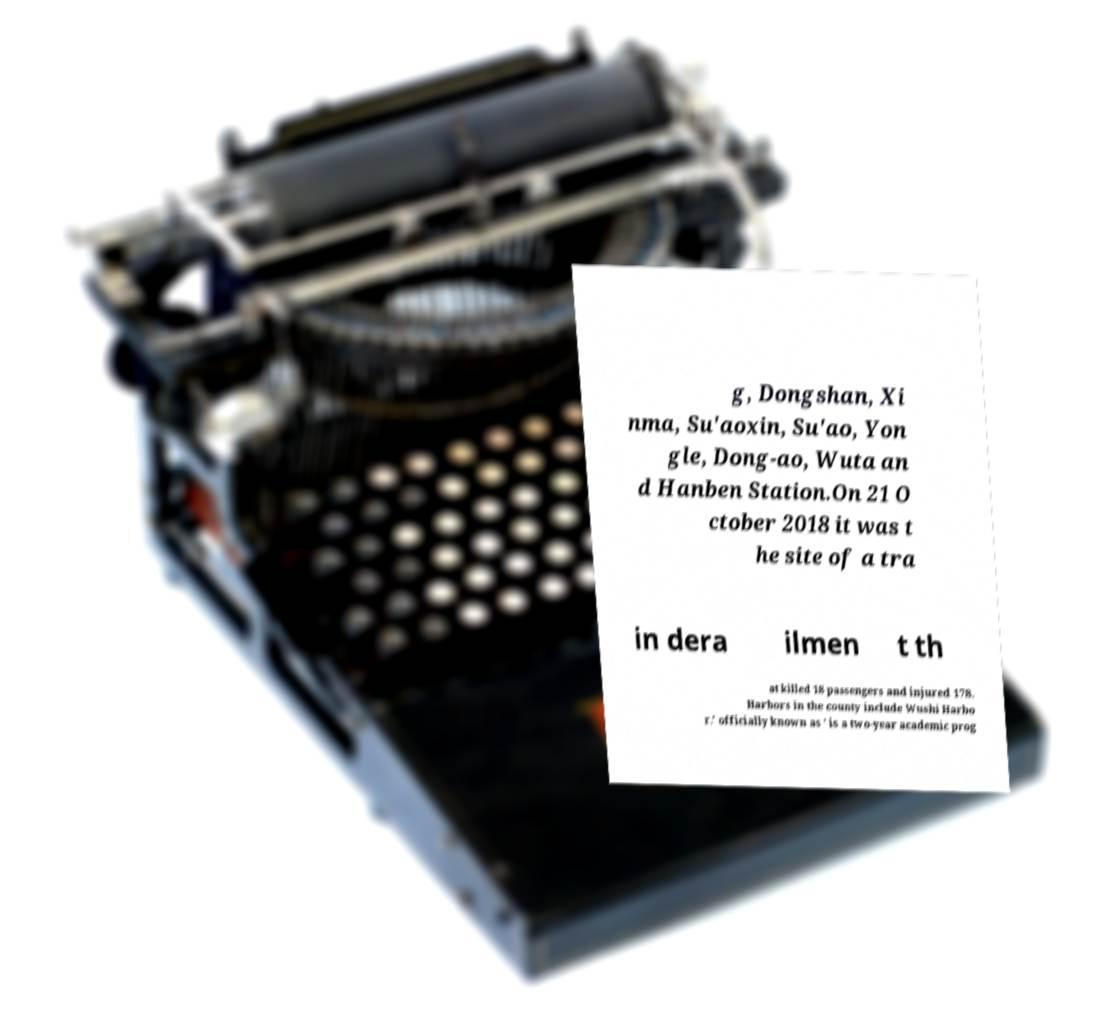Could you assist in decoding the text presented in this image and type it out clearly? g, Dongshan, Xi nma, Su'aoxin, Su'ao, Yon gle, Dong-ao, Wuta an d Hanben Station.On 21 O ctober 2018 it was t he site of a tra in dera ilmen t th at killed 18 passengers and injured 178. Harbors in the county include Wushi Harbo r.' officially known as ' is a two-year academic prog 